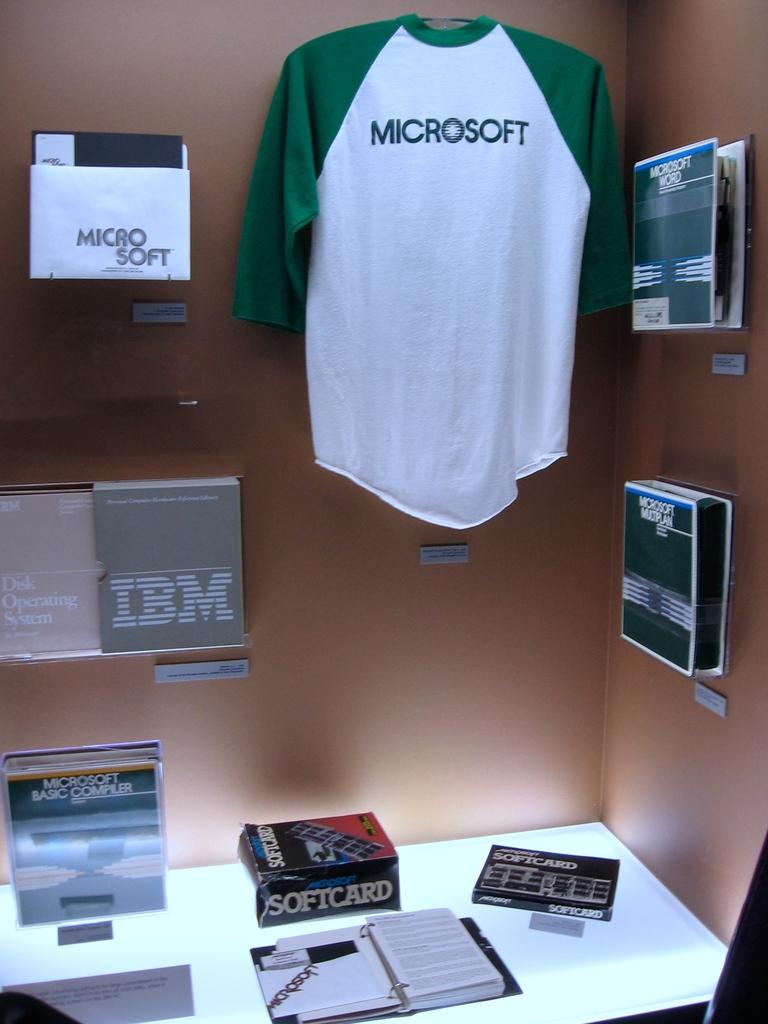<image>
Relay a brief, clear account of the picture shown. A Microsoft shirt hangs on the wall above a desk. 